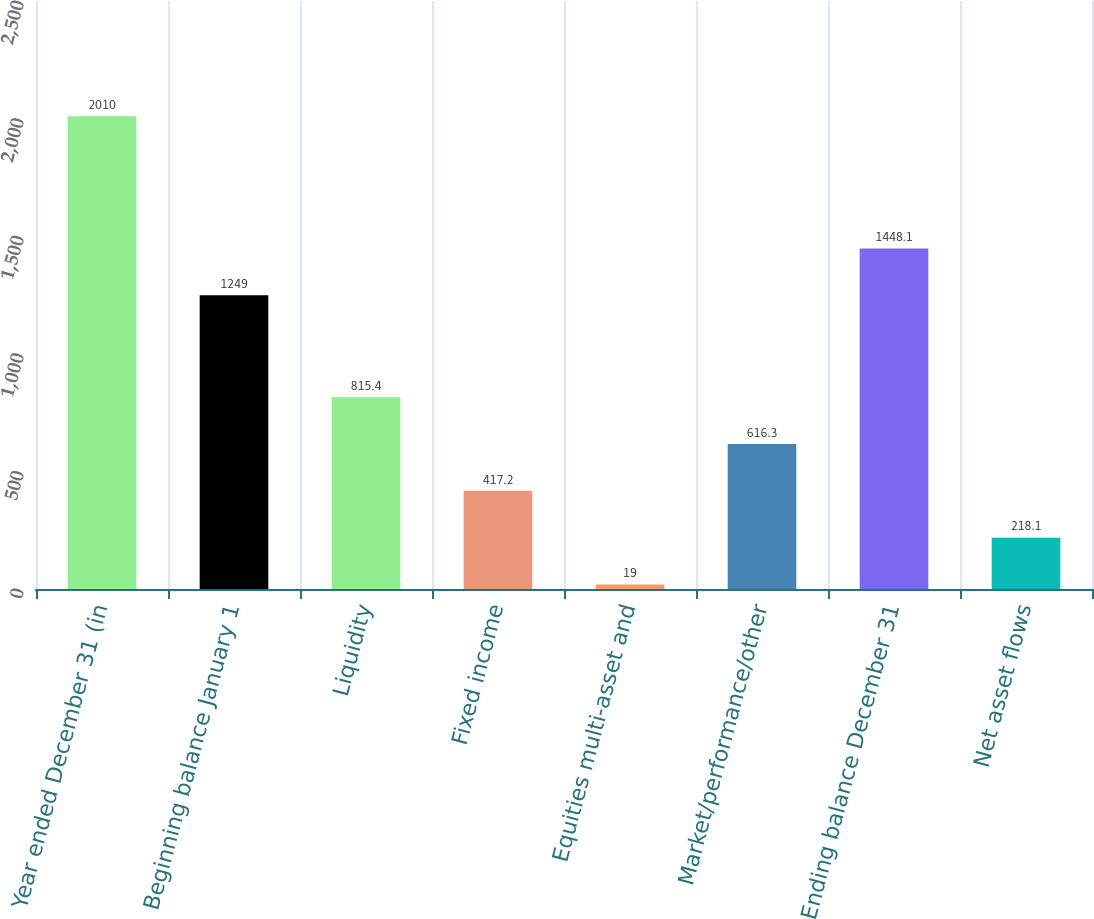Convert chart. <chart><loc_0><loc_0><loc_500><loc_500><bar_chart><fcel>Year ended December 31 (in<fcel>Beginning balance January 1<fcel>Liquidity<fcel>Fixed income<fcel>Equities multi-asset and<fcel>Market/performance/other<fcel>Ending balance December 31<fcel>Net asset flows<nl><fcel>2010<fcel>1249<fcel>815.4<fcel>417.2<fcel>19<fcel>616.3<fcel>1448.1<fcel>218.1<nl></chart> 